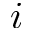<formula> <loc_0><loc_0><loc_500><loc_500>i</formula> 